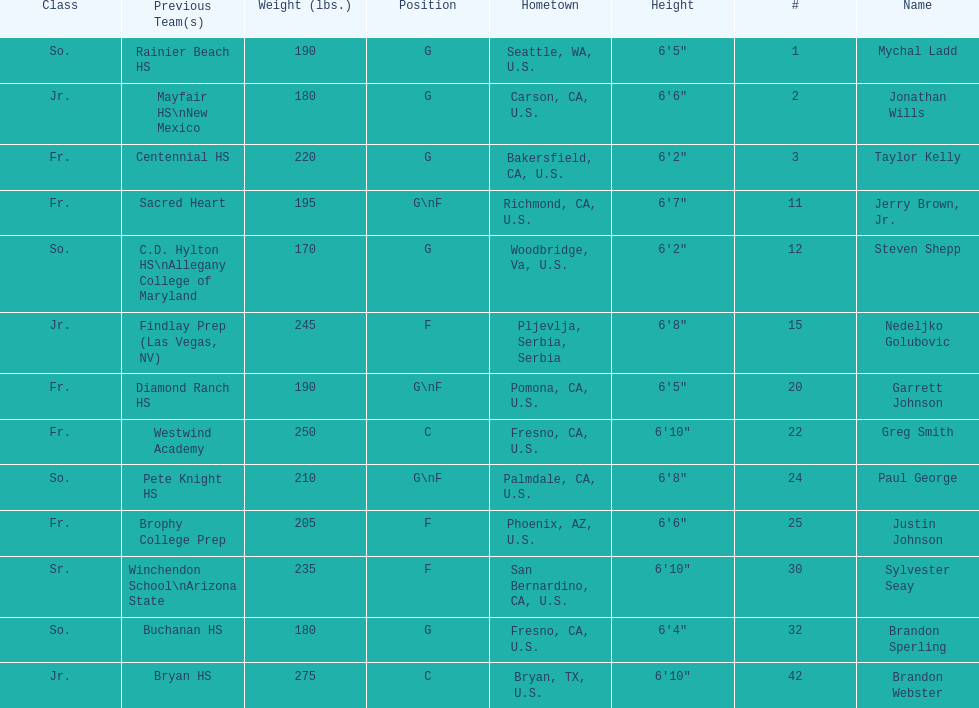How many players hometowns are outside of california? 5. Can you parse all the data within this table? {'header': ['Class', 'Previous Team(s)', 'Weight (lbs.)', 'Position', 'Hometown', 'Height', '#', 'Name'], 'rows': [['So.', 'Rainier Beach HS', '190', 'G', 'Seattle, WA, U.S.', '6\'5"', '1', 'Mychal Ladd'], ['Jr.', 'Mayfair HS\\nNew Mexico', '180', 'G', 'Carson, CA, U.S.', '6\'6"', '2', 'Jonathan Wills'], ['Fr.', 'Centennial HS', '220', 'G', 'Bakersfield, CA, U.S.', '6\'2"', '3', 'Taylor Kelly'], ['Fr.', 'Sacred Heart', '195', 'G\\nF', 'Richmond, CA, U.S.', '6\'7"', '11', 'Jerry Brown, Jr.'], ['So.', 'C.D. Hylton HS\\nAllegany College of Maryland', '170', 'G', 'Woodbridge, Va, U.S.', '6\'2"', '12', 'Steven Shepp'], ['Jr.', 'Findlay Prep (Las Vegas, NV)', '245', 'F', 'Pljevlja, Serbia, Serbia', '6\'8"', '15', 'Nedeljko Golubovic'], ['Fr.', 'Diamond Ranch HS', '190', 'G\\nF', 'Pomona, CA, U.S.', '6\'5"', '20', 'Garrett Johnson'], ['Fr.', 'Westwind Academy', '250', 'C', 'Fresno, CA, U.S.', '6\'10"', '22', 'Greg Smith'], ['So.', 'Pete Knight HS', '210', 'G\\nF', 'Palmdale, CA, U.S.', '6\'8"', '24', 'Paul George'], ['Fr.', 'Brophy College Prep', '205', 'F', 'Phoenix, AZ, U.S.', '6\'6"', '25', 'Justin Johnson'], ['Sr.', 'Winchendon School\\nArizona State', '235', 'F', 'San Bernardino, CA, U.S.', '6\'10"', '30', 'Sylvester Seay'], ['So.', 'Buchanan HS', '180', 'G', 'Fresno, CA, U.S.', '6\'4"', '32', 'Brandon Sperling'], ['Jr.', 'Bryan HS', '275', 'C', 'Bryan, TX, U.S.', '6\'10"', '42', 'Brandon Webster']]} 